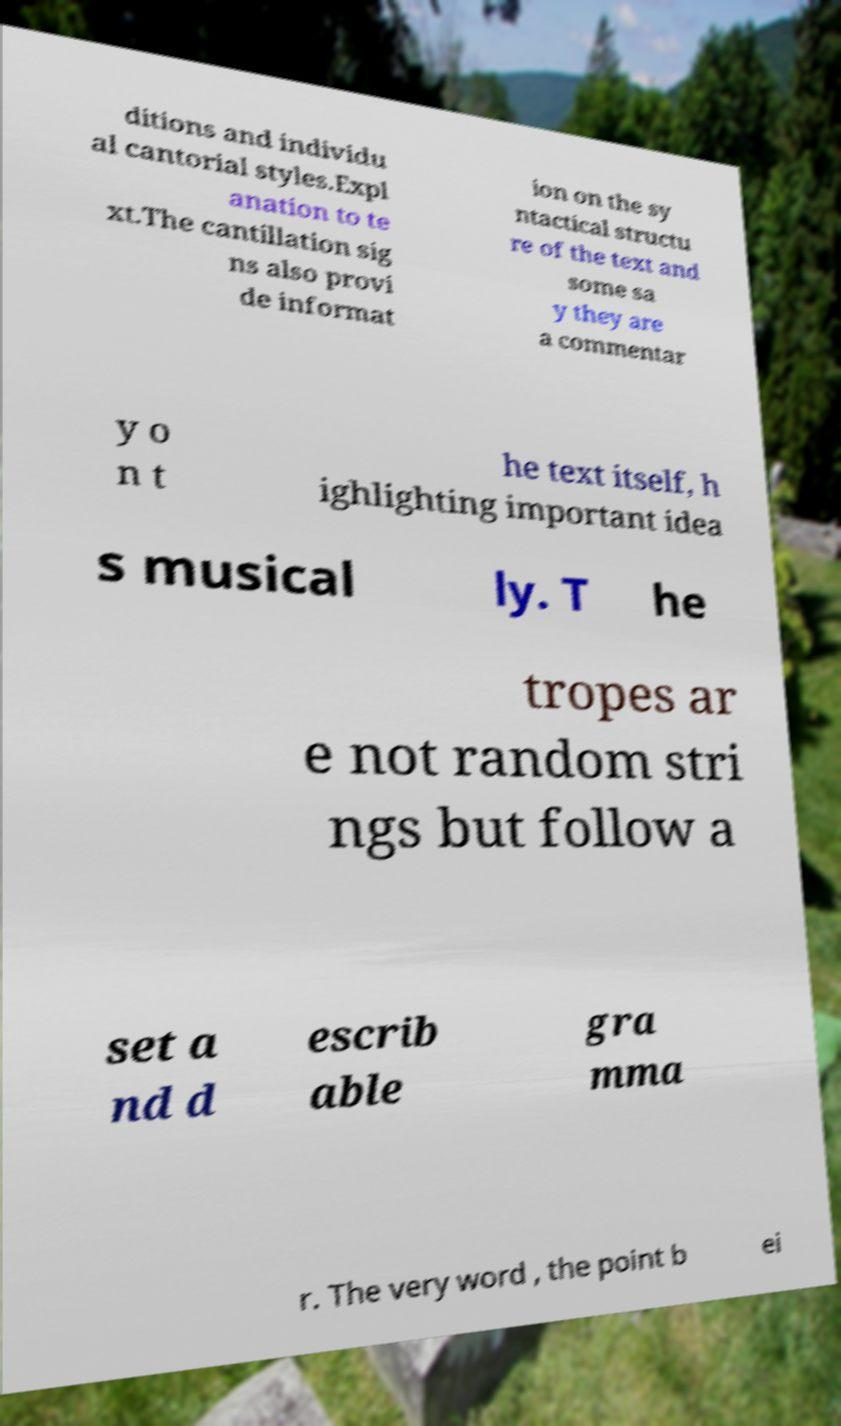For documentation purposes, I need the text within this image transcribed. Could you provide that? ditions and individu al cantorial styles.Expl anation to te xt.The cantillation sig ns also provi de informat ion on the sy ntactical structu re of the text and some sa y they are a commentar y o n t he text itself, h ighlighting important idea s musical ly. T he tropes ar e not random stri ngs but follow a set a nd d escrib able gra mma r. The very word , the point b ei 